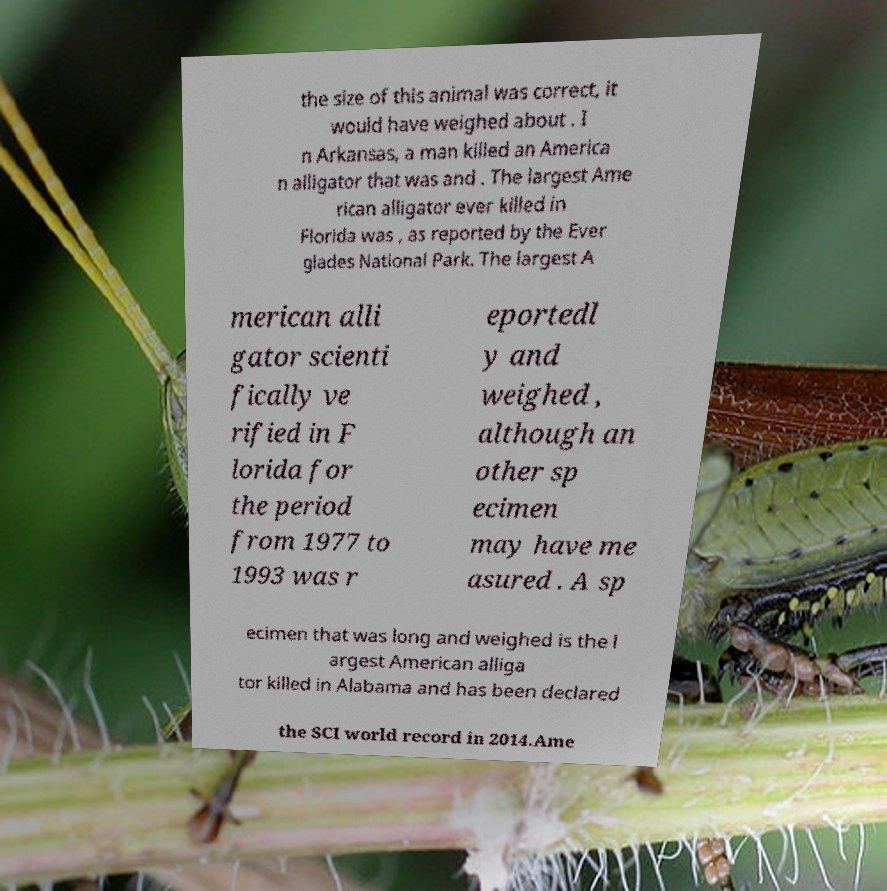Please identify and transcribe the text found in this image. the size of this animal was correct, it would have weighed about . I n Arkansas, a man killed an America n alligator that was and . The largest Ame rican alligator ever killed in Florida was , as reported by the Ever glades National Park. The largest A merican alli gator scienti fically ve rified in F lorida for the period from 1977 to 1993 was r eportedl y and weighed , although an other sp ecimen may have me asured . A sp ecimen that was long and weighed is the l argest American alliga tor killed in Alabama and has been declared the SCI world record in 2014.Ame 